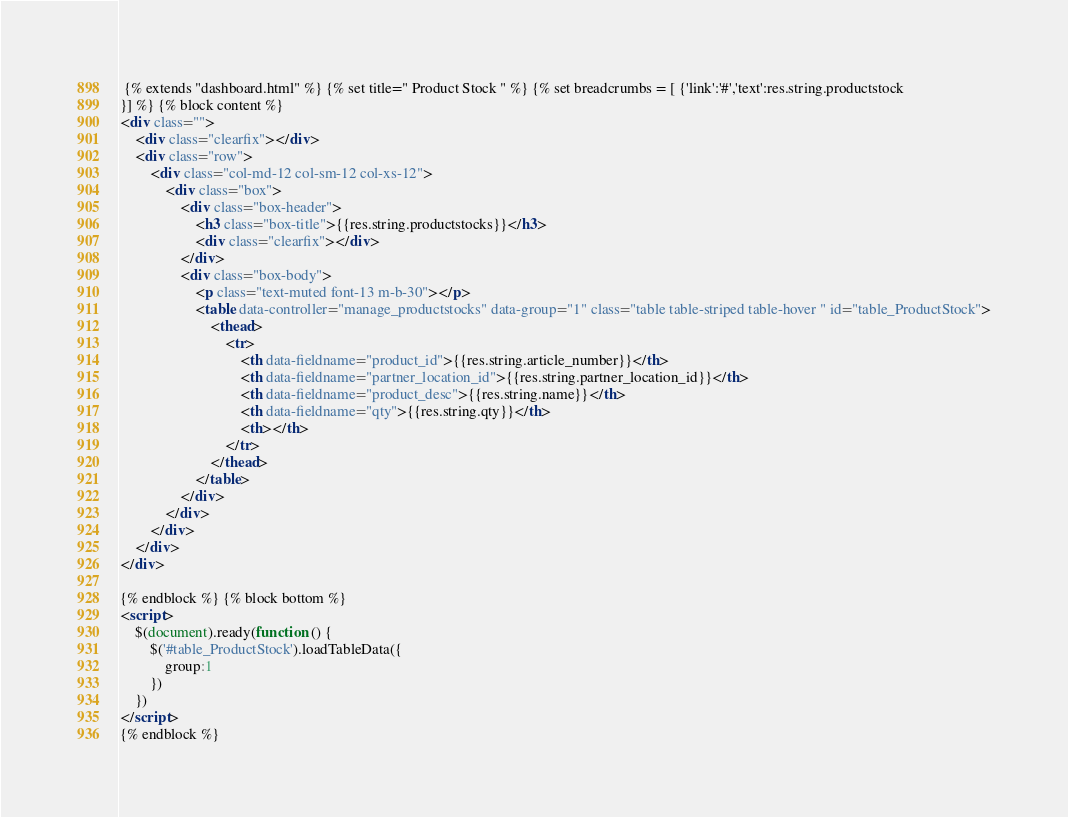Convert code to text. <code><loc_0><loc_0><loc_500><loc_500><_HTML_> {% extends "dashboard.html" %} {% set title=" Product Stock " %} {% set breadcrumbs = [ {'link':'#','text':res.string.productstock
}] %} {% block content %}
<div class="">
	<div class="clearfix"></div>
	<div class="row">
		<div class="col-md-12 col-sm-12 col-xs-12">
			<div class="box">
				<div class="box-header">
					<h3 class="box-title">{{res.string.productstocks}}</h3>
					<div class="clearfix"></div>
				</div>
				<div class="box-body">
					<p class="text-muted font-13 m-b-30"></p>
					<table data-controller="manage_productstocks" data-group="1" class="table table-striped table-hover " id="table_ProductStock">
						<thead>
							<tr>
								<th data-fieldname="product_id">{{res.string.article_number}}</th>
								<th data-fieldname="partner_location_id">{{res.string.partner_location_id}}</th>
								<th data-fieldname="product_desc">{{res.string.name}}</th>
								<th data-fieldname="qty">{{res.string.qty}}</th>
								<th></th>
							</tr>
						</thead>
					</table>
				</div>
			</div>
		</div>
	</div>
</div>

{% endblock %} {% block bottom %}
<script>
	$(document).ready(function () {
		$('#table_ProductStock').loadTableData({
			group:1
		})
	})
</script>
{% endblock %}</code> 